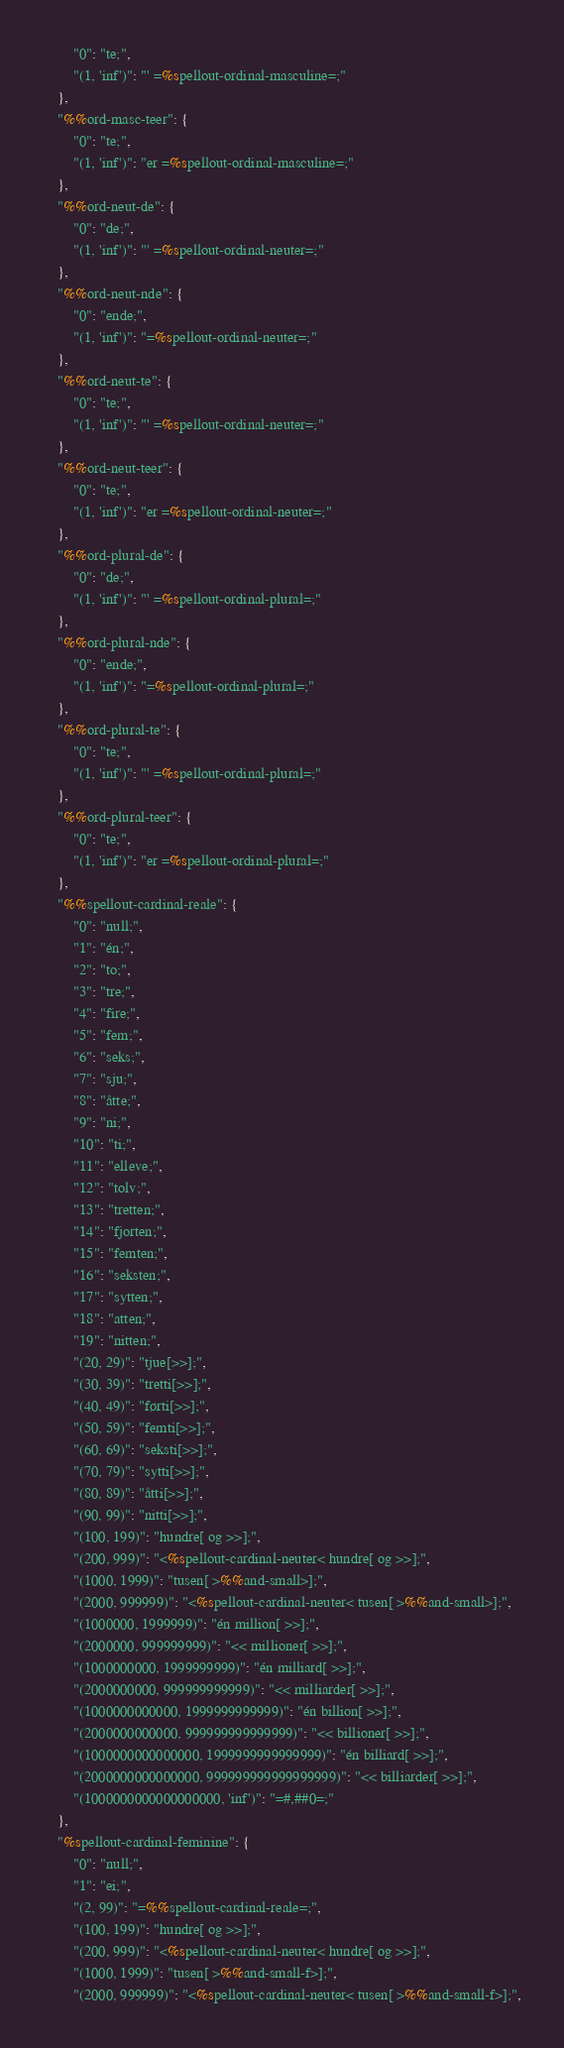Convert code to text. <code><loc_0><loc_0><loc_500><loc_500><_Python_>        "0": "te;",
        "(1, 'inf')": "' =%spellout-ordinal-masculine=;"
    },
    "%%ord-masc-teer": {
        "0": "te;",
        "(1, 'inf')": "er =%spellout-ordinal-masculine=;"
    },
    "%%ord-neut-de": {
        "0": "de;",
        "(1, 'inf')": "' =%spellout-ordinal-neuter=;"
    },
    "%%ord-neut-nde": {
        "0": "ende;",
        "(1, 'inf')": "­=%spellout-ordinal-neuter=;"
    },
    "%%ord-neut-te": {
        "0": "te;",
        "(1, 'inf')": "' =%spellout-ordinal-neuter=;"
    },
    "%%ord-neut-teer": {
        "0": "te;",
        "(1, 'inf')": "er =%spellout-ordinal-neuter=;"
    },
    "%%ord-plural-de": {
        "0": "de;",
        "(1, 'inf')": "' =%spellout-ordinal-plural=;"
    },
    "%%ord-plural-nde": {
        "0": "ende;",
        "(1, 'inf')": "­=%spellout-ordinal-plural=;"
    },
    "%%ord-plural-te": {
        "0": "te;",
        "(1, 'inf')": "' =%spellout-ordinal-plural=;"
    },
    "%%ord-plural-teer": {
        "0": "te;",
        "(1, 'inf')": "er =%spellout-ordinal-plural=;"
    },
    "%%spellout-cardinal-reale": {
        "0": "null;",
        "1": "én;",
        "2": "to;",
        "3": "tre;",
        "4": "fire;",
        "5": "fem;",
        "6": "seks;",
        "7": "sju;",
        "8": "åtte;",
        "9": "ni;",
        "10": "ti;",
        "11": "elleve;",
        "12": "tolv;",
        "13": "tretten;",
        "14": "fjorten;",
        "15": "femten;",
        "16": "seksten;",
        "17": "sytten;",
        "18": "atten;",
        "19": "nitten;",
        "(20, 29)": "tjue[­>>];",
        "(30, 39)": "tretti[­>>];",
        "(40, 49)": "førti[­>>];",
        "(50, 59)": "femti[­>>];",
        "(60, 69)": "seksti[­>>];",
        "(70, 79)": "sytti[­>>];",
        "(80, 89)": "åtti[­>>];",
        "(90, 99)": "nitti[­>>];",
        "(100, 199)": "hundre[ og >>];",
        "(200, 999)": "<%spellout-cardinal-neuter< hundre[ og >>];",
        "(1000, 1999)": "tusen[ >%%and-small>];",
        "(2000, 999999)": "<%spellout-cardinal-neuter< tusen[ >%%and-small>];",
        "(1000000, 1999999)": "én million[ >>];",
        "(2000000, 999999999)": "<< millioner[ >>];",
        "(1000000000, 1999999999)": "én milliard[ >>];",
        "(2000000000, 999999999999)": "<< milliarder[ >>];",
        "(1000000000000, 1999999999999)": "én billion[ >>];",
        "(2000000000000, 999999999999999)": "<< billioner[ >>];",
        "(1000000000000000, 1999999999999999)": "én billiard[ >>];",
        "(2000000000000000, 999999999999999999)": "<< billiarder[ >>];",
        "(1000000000000000000, 'inf')": "=#,##0=;"
    },
    "%spellout-cardinal-feminine": {
        "0": "null;",
        "1": "ei;",
        "(2, 99)": "=%%spellout-cardinal-reale=;",
        "(100, 199)": "hundre[ og >>];",
        "(200, 999)": "<%spellout-cardinal-neuter< hundre[ og >>];",
        "(1000, 1999)": "tusen[ >%%and-small-f>];",
        "(2000, 999999)": "<%spellout-cardinal-neuter< tusen[ >%%and-small-f>];",</code> 